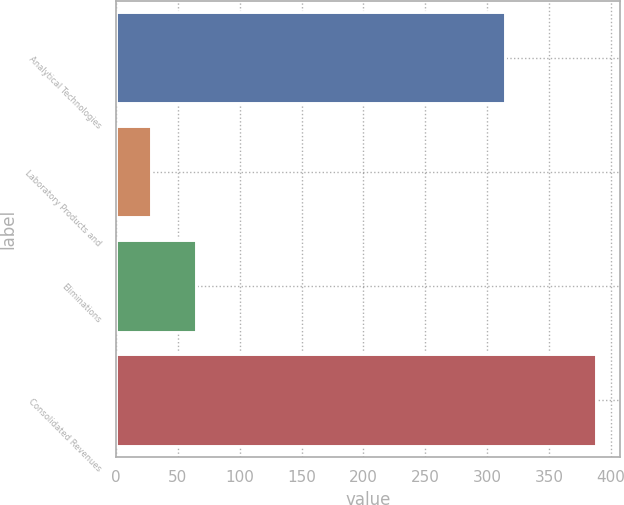Convert chart. <chart><loc_0><loc_0><loc_500><loc_500><bar_chart><fcel>Analytical Technologies<fcel>Laboratory Products and<fcel>Eliminations<fcel>Consolidated Revenues<nl><fcel>314.7<fcel>28.6<fcel>64.57<fcel>388.3<nl></chart> 